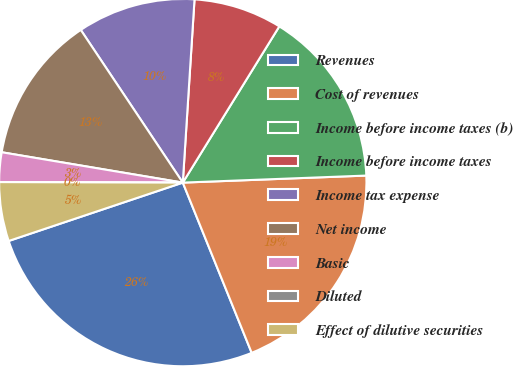<chart> <loc_0><loc_0><loc_500><loc_500><pie_chart><fcel>Revenues<fcel>Cost of revenues<fcel>Income before income taxes (b)<fcel>Income before income taxes<fcel>Income tax expense<fcel>Net income<fcel>Basic<fcel>Diluted<fcel>Effect of dilutive securities<nl><fcel>25.97%<fcel>19.49%<fcel>15.58%<fcel>7.79%<fcel>10.39%<fcel>12.98%<fcel>2.6%<fcel>0.0%<fcel>5.19%<nl></chart> 